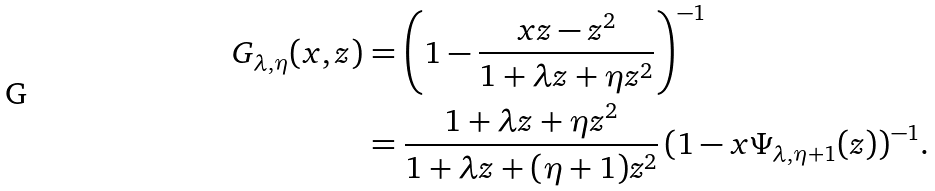<formula> <loc_0><loc_0><loc_500><loc_500>G _ { \lambda , \eta } ( x , z ) & = \left ( 1 - \frac { x z - z ^ { 2 } } { 1 + \lambda z + \eta z ^ { 2 } } \right ) ^ { - 1 } \\ & = \frac { 1 + \lambda z + \eta z ^ { 2 } } { 1 + \lambda z + ( \eta + 1 ) z ^ { 2 } } \, ( 1 - x \Psi _ { \lambda , \eta + 1 } ( z ) ) ^ { - 1 } .</formula> 